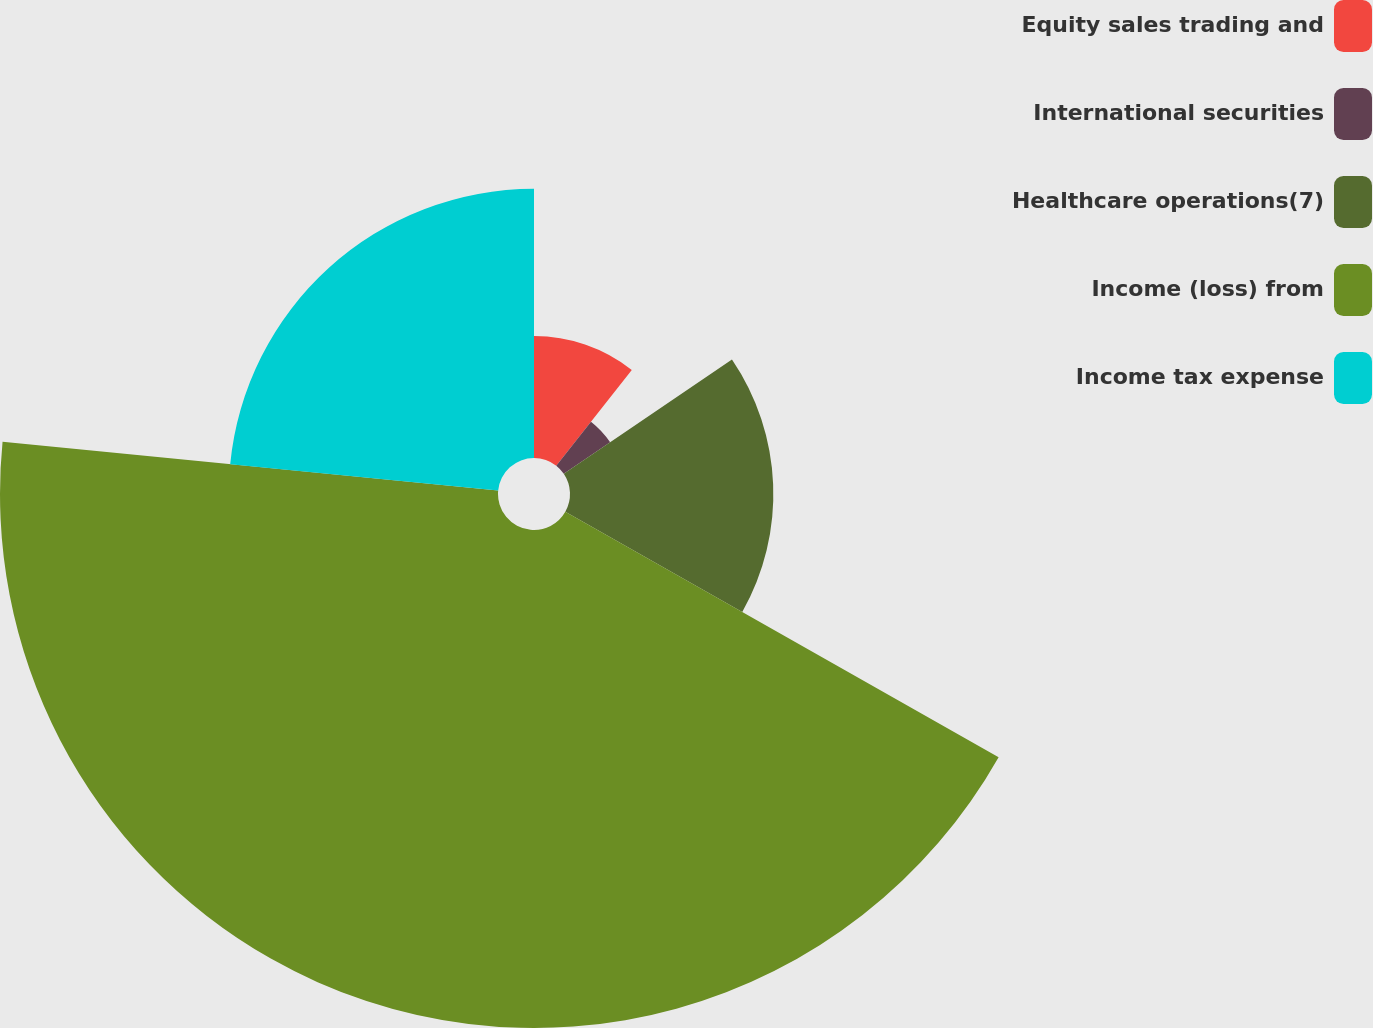Convert chart. <chart><loc_0><loc_0><loc_500><loc_500><pie_chart><fcel>Equity sales trading and<fcel>International securities<fcel>Healthcare operations(7)<fcel>Income (loss) from<fcel>Income tax expense<nl><fcel>10.62%<fcel>4.88%<fcel>17.7%<fcel>43.35%<fcel>23.44%<nl></chart> 